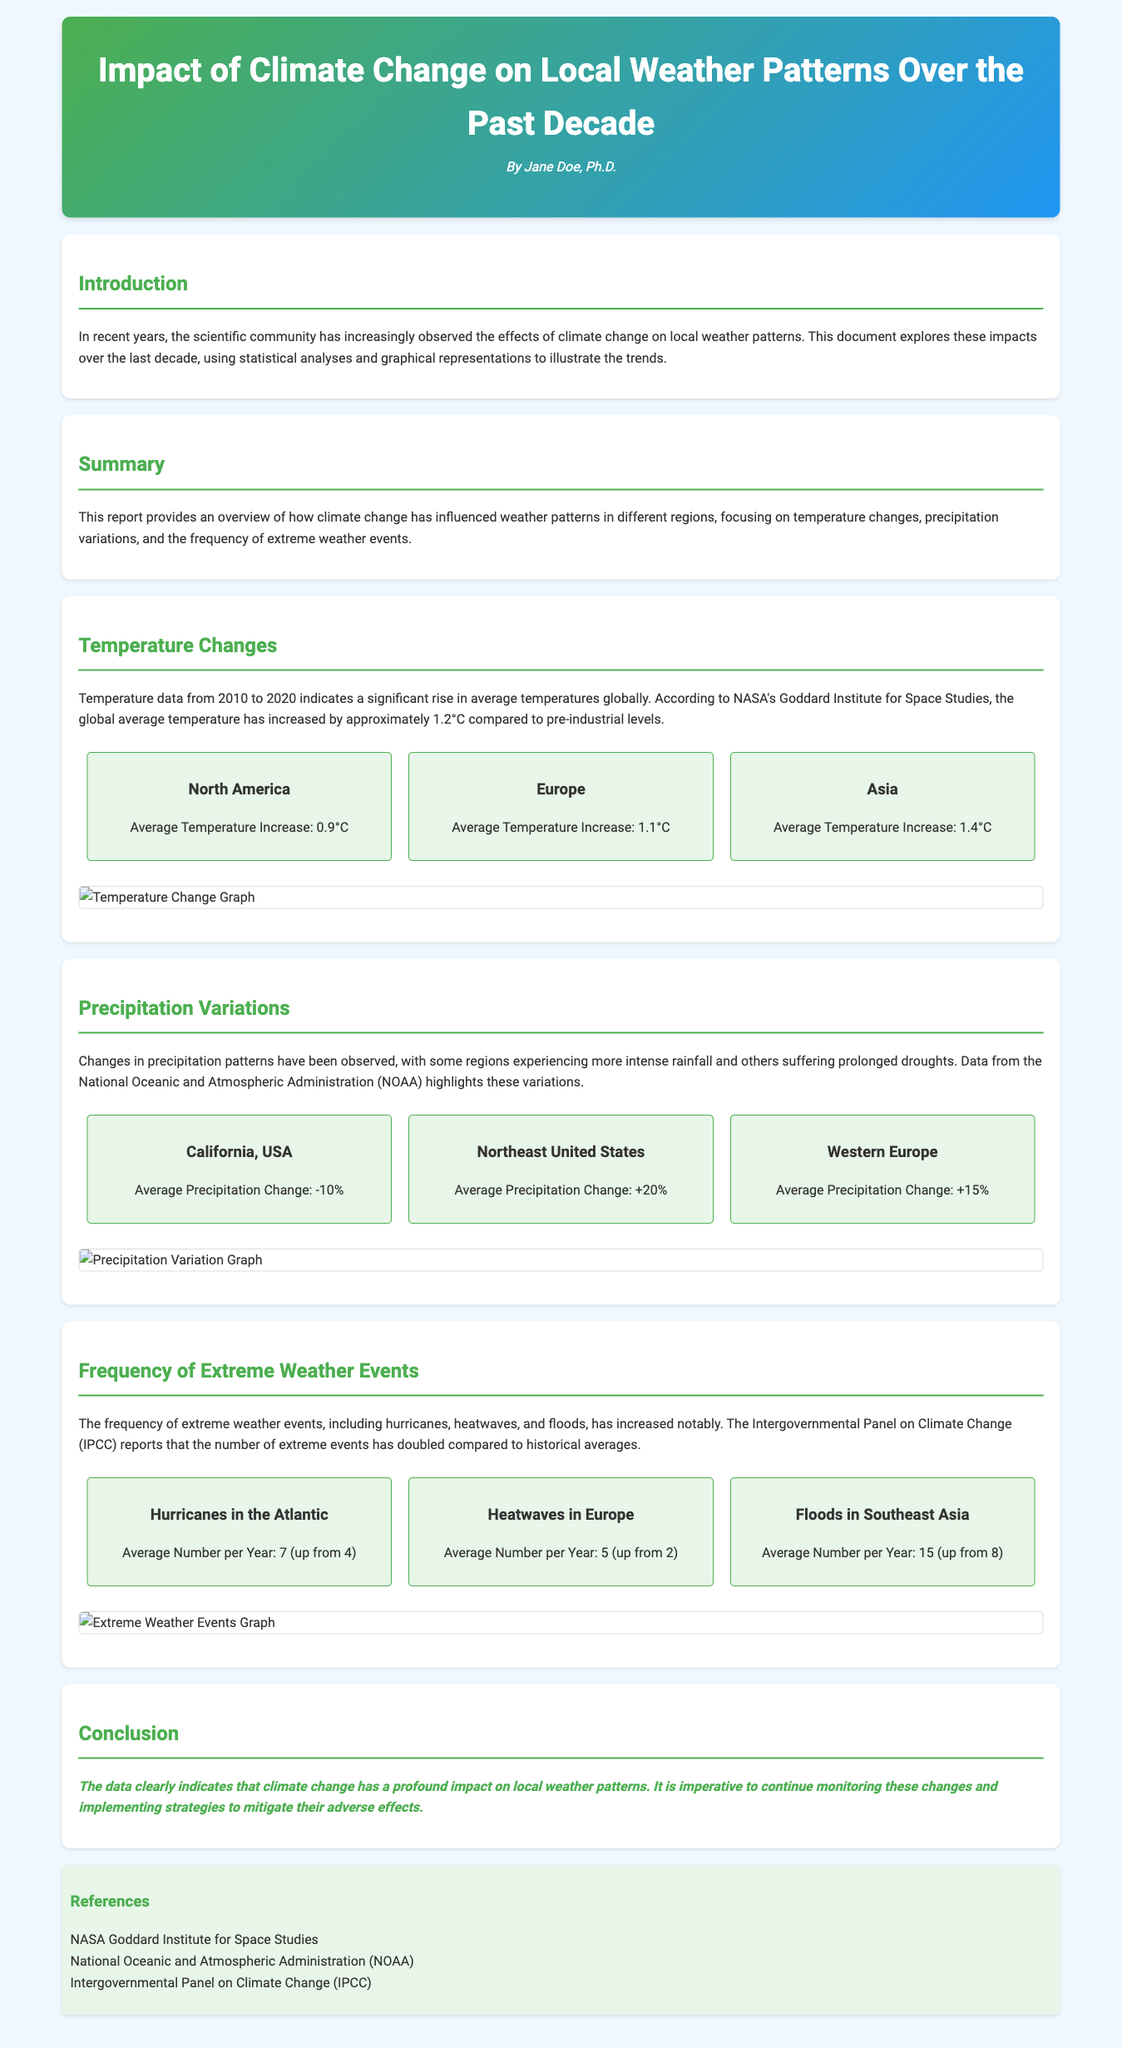What is the overall temperature increase since pre-industrial levels? The overall temperature increase since pre-industrial levels is provided as 1.2°C according to NASA's findings.
Answer: 1.2°C What was the average temperature increase in Asia? The average temperature increase in Asia is explicitly stated as 1.4°C in the report.
Answer: 1.4°C What percentage change in precipitation is observed in California, USA? The report specifies that California, USA experienced an average precipitation change of -10%.
Answer: -10% How many hurricanes on average occur in the Atlantic per year now? The document indicates that the average number of hurricanes in the Atlantic has increased to 7 per year, up from 4.
Answer: 7 What was the average number of heatwaves in Europe per year before the increase? The report states that the average number of heatwaves in Europe was 2 before the increase to 5.
Answer: 2 What source reported the increase in extreme weather events? The Intergovernmental Panel on Climate Change (IPCC) is mentioned as the source reporting the increase.
Answer: IPCC How has average precipitation changed in the Northeast United States? The report indicates that the Northeast United States has seen an average precipitation change of +20%.
Answer: +20% What color is used for the headers in the document? The headers are styled to be colored in a specific green hue defined in the CSS.
Answer: Green 